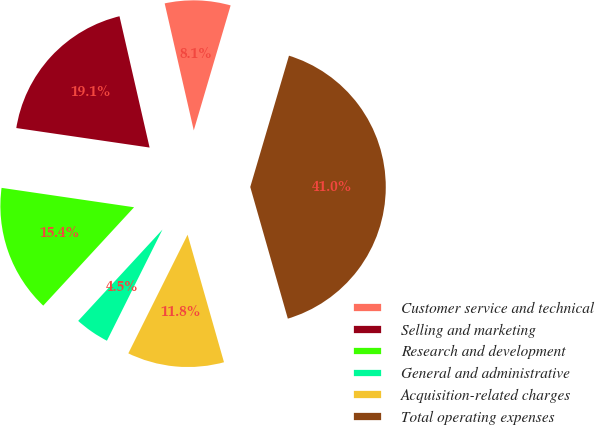<chart> <loc_0><loc_0><loc_500><loc_500><pie_chart><fcel>Customer service and technical<fcel>Selling and marketing<fcel>Research and development<fcel>General and administrative<fcel>Acquisition-related charges<fcel>Total operating expenses<nl><fcel>8.15%<fcel>19.1%<fcel>15.45%<fcel>4.49%<fcel>11.8%<fcel>41.01%<nl></chart> 